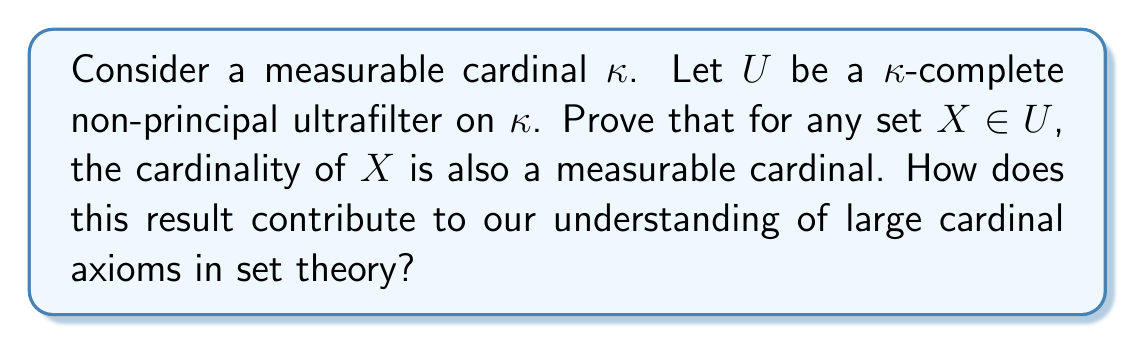Can you solve this math problem? To prove this, we'll follow these steps:

1) First, recall that a cardinal $\kappa$ is measurable if there exists a $\kappa$-complete non-principal ultrafilter on $\kappa$.

2) Let $X \in U$, where $U$ is a $\kappa$-complete non-principal ultrafilter on $\kappa$.

3) Define a new ultrafilter $V$ on $X$ as follows:
   $$V = \{A \subseteq X : A \in U\}$$

4) We need to show that $V$ is an $|X|$-complete non-principal ultrafilter on $X$:

   a) $V$ is an ultrafilter:
      - If $A \in V$ and $A \subseteq B \subseteq X$, then $B \in U$ (since $U$ is an ultrafilter), so $B \in V$.
      - If $A, B \in V$, then $A \cap B \in U$ (since $U$ is an ultrafilter), so $A \cap B \in V$.
      - For any $A \subseteq X$, either $A \in U$ or $X \setminus A \in U$ (since $U$ is an ultrafilter), so either $A \in V$ or $X \setminus A \in V$.

   b) $V$ is non-principal:
      If $V$ were principal, there would be some $x \in X$ such that $\{x\} \in V$. But then $\{x\} \in U$, contradicting that $U$ is non-principal.

   c) $V$ is $|X|$-complete:
      Let $\lambda < |X|$ and let $\{A_\alpha : \alpha < \lambda\}$ be a collection of sets in $V$. Then $\{A_\alpha : \alpha < \lambda\} \subseteq U$. Since $\lambda < |X| \leq \kappa$ and $U$ is $\kappa$-complete, we have $\bigcap_{\alpha < \lambda} A_\alpha \in U$. Therefore, $\bigcap_{\alpha < \lambda} A_\alpha \in V$.

5) Thus, $V$ is an $|X|$-complete non-principal ultrafilter on $X$, proving that $|X|$ is a measurable cardinal.

This result contributes to our understanding of large cardinal axioms in set theory by showing that measurable cardinals have a strong closure property: any set in the ultrafilter witnessing the measurability of a cardinal is itself of measurable size. This demonstrates the robustness of measurable cardinals and helps explain why they play a crucial role in the hierarchy of large cardinals.

Moreover, this property is characteristic of measurable cardinals and distinguishes them from smaller large cardinals. It provides insight into the structure of the cumulative hierarchy $V$ above a measurable cardinal, showing that there are many measurable cardinals below any given measurable cardinal.
Answer: For any set $X$ in the $\kappa$-complete non-principal ultrafilter $U$ on a measurable cardinal $\kappa$, the cardinality of $X$ is also a measurable cardinal. This result demonstrates the strong closure properties of measurable cardinals and their significance in the hierarchy of large cardinal axioms. 